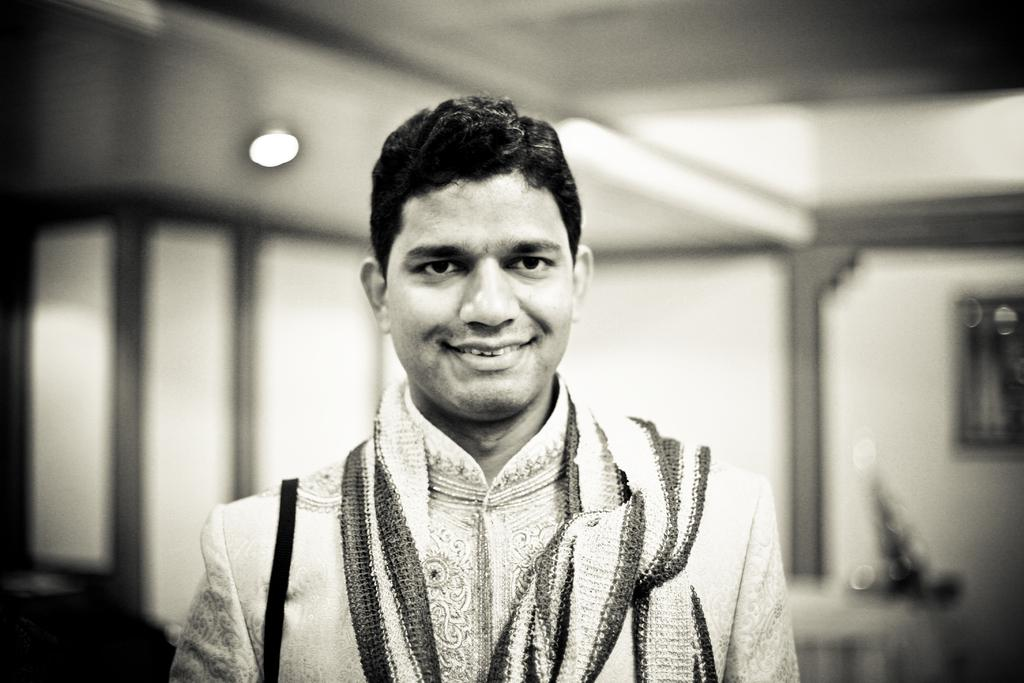What is the main subject of the image? There is a man in the middle of the image. What is the man's facial expression? The man is smiling. Can you describe the background of the image? There appears to be a light in the background of the image. What is the color scheme of the image? The image is in black and white color. What type of vessel is the man using to drink in the image? There is no vessel or drinking activity present in the image. What game is the man playing in the image? There is no game or play activity depicted in the image. 